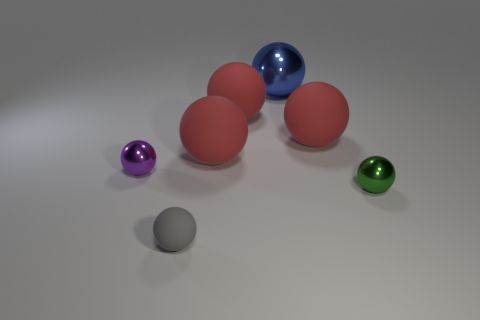Are there any small gray rubber things on the right side of the tiny metallic object on the right side of the purple sphere?
Ensure brevity in your answer.  No. What number of cylinders are either tiny cyan matte objects or small purple objects?
Give a very brief answer. 0. How big is the metal sphere that is to the left of the object in front of the small metallic object that is in front of the purple metal thing?
Ensure brevity in your answer.  Small. There is a gray ball; are there any purple objects behind it?
Keep it short and to the point. Yes. What number of things are either tiny things that are to the left of the green thing or big matte spheres?
Your answer should be compact. 5. What size is the blue sphere that is made of the same material as the tiny purple sphere?
Keep it short and to the point. Large. Does the blue thing have the same size as the matte object that is to the right of the blue sphere?
Offer a very short reply. Yes. What color is the shiny object that is to the right of the gray object and in front of the blue object?
Provide a short and direct response. Green. What number of things are either small metallic objects left of the gray rubber thing or purple spheres behind the gray ball?
Your answer should be very brief. 1. There is a tiny shiny ball that is in front of the tiny sphere behind the tiny ball that is on the right side of the tiny matte ball; what is its color?
Your answer should be compact. Green. 